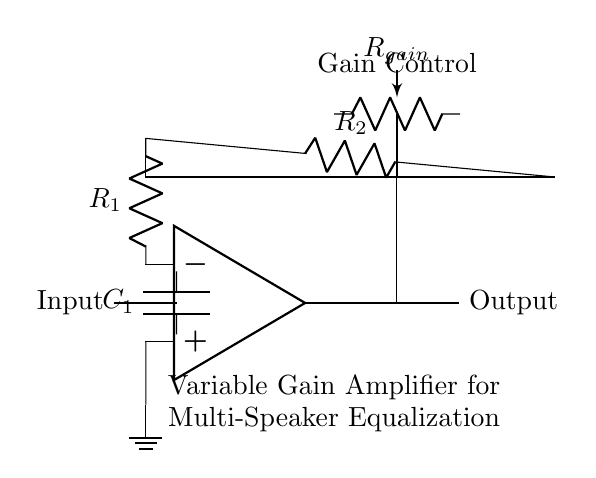What type of amplifier is shown in the circuit? The circuit is a variable gain amplifier, as indicated by the presence of a variable resistor labeled as gain control and the operational amplifier configuration.
Answer: variable gain amplifier What is the purpose of the potentiometer labeled R gain? The potentiometer R gain is used to adjust the gain of the amplifier, allowing for variable amplification of the input signal, which is essential for equalizing sound levels in a multi-speaker system.
Answer: adjust gain How many resistors are present in this circuit? There are two resistors in the feedback network, R one and R two, shown connected in series.
Answer: two What component is connected to the non-inverting input of the operational amplifier? The ground is connected to the non-inverting input of the operational amplifier, which stabilizes the reference voltage for the amplifier circuit.
Answer: ground What is the function of the capacitor labeled C one? The capacitor C one is used to block any DC voltage from the input signal, allowing only the AC audio signals to pass through to the amplifier.
Answer: block DC What is the significance of the feedback resistors in this circuit? The feedback resistors, R one and R two, set the gain of the operational amplifier, determining how much the input signal will be amplified by the circuit.
Answer: set gain Where is the output signal taken from in the circuit? The output signal is taken from the output terminal of the operational amplifier, shown in the circuit as leading to the output node.
Answer: output terminal 